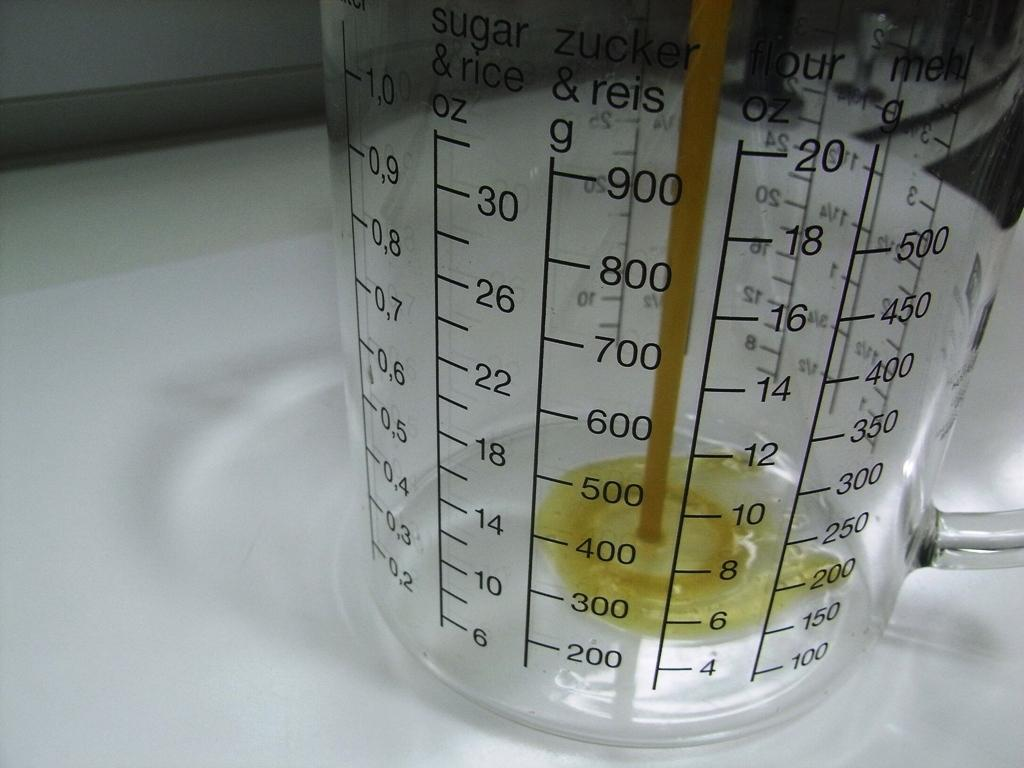What is the main object in the image? There is a measuring jar in the image. What is inside the measuring jar? The measuring jar contains liquid. What is the measuring jar placed on? The measuring jar is on a white object. What type of drum can be seen in the image? There is no drum present in the image; it features a measuring jar with liquid on a white object. Is there a turkey visible in the image? No, there is no turkey present in the image. 